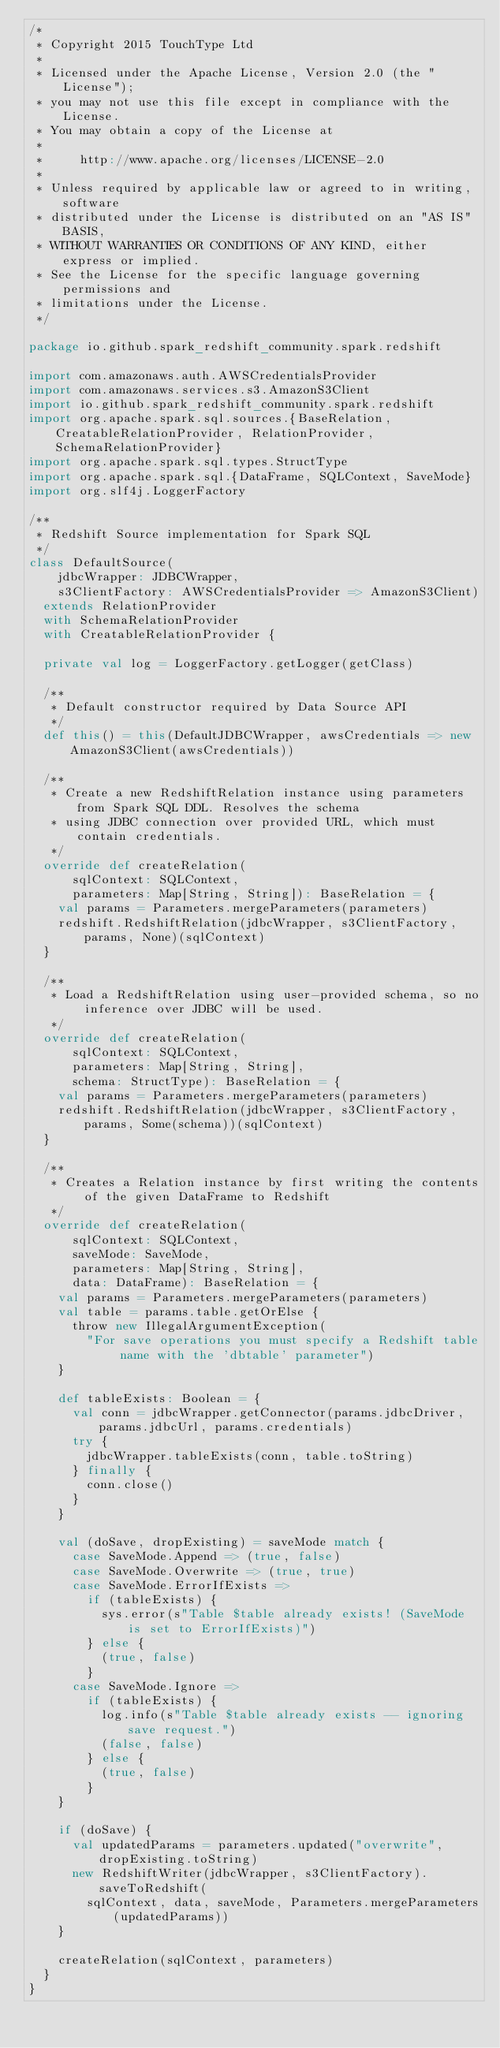<code> <loc_0><loc_0><loc_500><loc_500><_Scala_>/*
 * Copyright 2015 TouchType Ltd
 *
 * Licensed under the Apache License, Version 2.0 (the "License");
 * you may not use this file except in compliance with the License.
 * You may obtain a copy of the License at
 *
 *     http://www.apache.org/licenses/LICENSE-2.0
 *
 * Unless required by applicable law or agreed to in writing, software
 * distributed under the License is distributed on an "AS IS" BASIS,
 * WITHOUT WARRANTIES OR CONDITIONS OF ANY KIND, either express or implied.
 * See the License for the specific language governing permissions and
 * limitations under the License.
 */

package io.github.spark_redshift_community.spark.redshift

import com.amazonaws.auth.AWSCredentialsProvider
import com.amazonaws.services.s3.AmazonS3Client
import io.github.spark_redshift_community.spark.redshift
import org.apache.spark.sql.sources.{BaseRelation, CreatableRelationProvider, RelationProvider, SchemaRelationProvider}
import org.apache.spark.sql.types.StructType
import org.apache.spark.sql.{DataFrame, SQLContext, SaveMode}
import org.slf4j.LoggerFactory

/**
 * Redshift Source implementation for Spark SQL
 */
class DefaultSource(
    jdbcWrapper: JDBCWrapper,
    s3ClientFactory: AWSCredentialsProvider => AmazonS3Client)
  extends RelationProvider
  with SchemaRelationProvider
  with CreatableRelationProvider {

  private val log = LoggerFactory.getLogger(getClass)

  /**
   * Default constructor required by Data Source API
   */
  def this() = this(DefaultJDBCWrapper, awsCredentials => new AmazonS3Client(awsCredentials))

  /**
   * Create a new RedshiftRelation instance using parameters from Spark SQL DDL. Resolves the schema
   * using JDBC connection over provided URL, which must contain credentials.
   */
  override def createRelation(
      sqlContext: SQLContext,
      parameters: Map[String, String]): BaseRelation = {
    val params = Parameters.mergeParameters(parameters)
    redshift.RedshiftRelation(jdbcWrapper, s3ClientFactory, params, None)(sqlContext)
  }

  /**
   * Load a RedshiftRelation using user-provided schema, so no inference over JDBC will be used.
   */
  override def createRelation(
      sqlContext: SQLContext,
      parameters: Map[String, String],
      schema: StructType): BaseRelation = {
    val params = Parameters.mergeParameters(parameters)
    redshift.RedshiftRelation(jdbcWrapper, s3ClientFactory, params, Some(schema))(sqlContext)
  }

  /**
   * Creates a Relation instance by first writing the contents of the given DataFrame to Redshift
   */
  override def createRelation(
      sqlContext: SQLContext,
      saveMode: SaveMode,
      parameters: Map[String, String],
      data: DataFrame): BaseRelation = {
    val params = Parameters.mergeParameters(parameters)
    val table = params.table.getOrElse {
      throw new IllegalArgumentException(
        "For save operations you must specify a Redshift table name with the 'dbtable' parameter")
    }

    def tableExists: Boolean = {
      val conn = jdbcWrapper.getConnector(params.jdbcDriver, params.jdbcUrl, params.credentials)
      try {
        jdbcWrapper.tableExists(conn, table.toString)
      } finally {
        conn.close()
      }
    }

    val (doSave, dropExisting) = saveMode match {
      case SaveMode.Append => (true, false)
      case SaveMode.Overwrite => (true, true)
      case SaveMode.ErrorIfExists =>
        if (tableExists) {
          sys.error(s"Table $table already exists! (SaveMode is set to ErrorIfExists)")
        } else {
          (true, false)
        }
      case SaveMode.Ignore =>
        if (tableExists) {
          log.info(s"Table $table already exists -- ignoring save request.")
          (false, false)
        } else {
          (true, false)
        }
    }

    if (doSave) {
      val updatedParams = parameters.updated("overwrite", dropExisting.toString)
      new RedshiftWriter(jdbcWrapper, s3ClientFactory).saveToRedshift(
        sqlContext, data, saveMode, Parameters.mergeParameters(updatedParams))
    }

    createRelation(sqlContext, parameters)
  }
}
</code> 